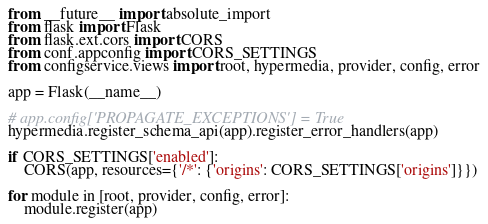Convert code to text. <code><loc_0><loc_0><loc_500><loc_500><_Python_>from __future__ import absolute_import
from flask import Flask
from flask.ext.cors import CORS
from conf.appconfig import CORS_SETTINGS
from configservice.views import root, hypermedia, provider, config, error

app = Flask(__name__)

# app.config['PROPAGATE_EXCEPTIONS'] = True
hypermedia.register_schema_api(app).register_error_handlers(app)

if CORS_SETTINGS['enabled']:
    CORS(app, resources={'/*': {'origins': CORS_SETTINGS['origins']}})

for module in [root, provider, config, error]:
    module.register(app)
</code> 